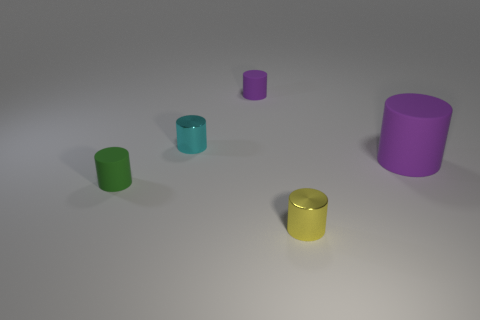How many big things are yellow balls or yellow metallic cylinders? 0 